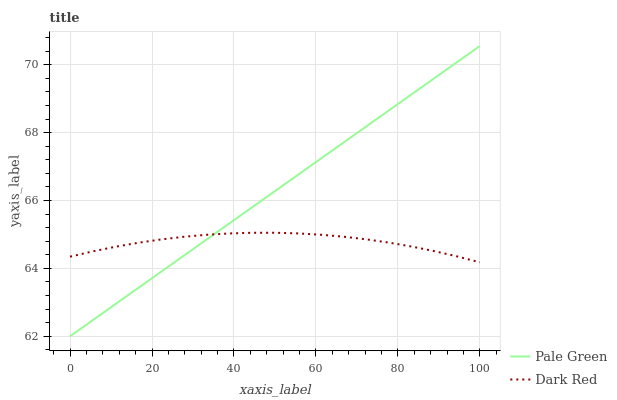Does Dark Red have the minimum area under the curve?
Answer yes or no. Yes. Does Pale Green have the maximum area under the curve?
Answer yes or no. Yes. Does Pale Green have the minimum area under the curve?
Answer yes or no. No. Is Pale Green the smoothest?
Answer yes or no. Yes. Is Dark Red the roughest?
Answer yes or no. Yes. Is Pale Green the roughest?
Answer yes or no. No. Does Pale Green have the lowest value?
Answer yes or no. Yes. Does Pale Green have the highest value?
Answer yes or no. Yes. Does Dark Red intersect Pale Green?
Answer yes or no. Yes. Is Dark Red less than Pale Green?
Answer yes or no. No. Is Dark Red greater than Pale Green?
Answer yes or no. No. 